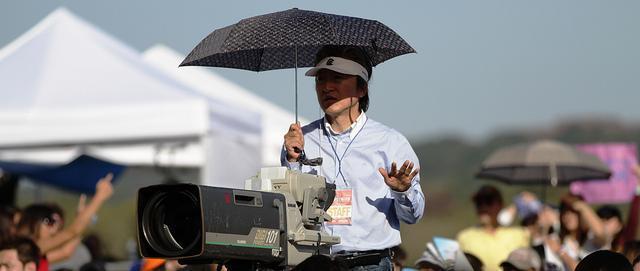How many umbrellas are there?
Give a very brief answer. 2. How many people can you see?
Give a very brief answer. 4. 